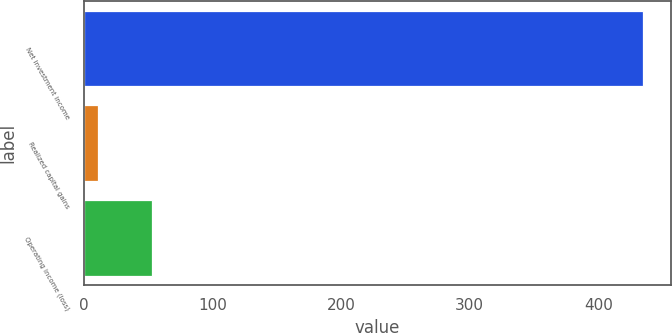Convert chart to OTSL. <chart><loc_0><loc_0><loc_500><loc_500><bar_chart><fcel>Net investment income<fcel>Realized capital gains<fcel>Operating income (loss)<nl><fcel>435<fcel>11<fcel>53.4<nl></chart> 